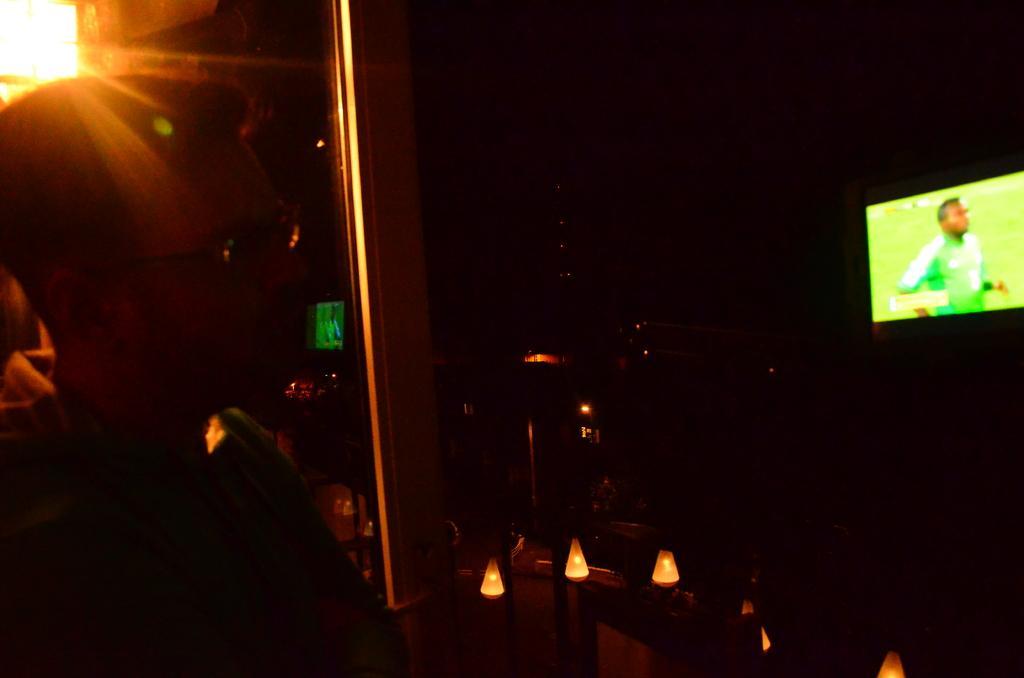Can you describe this image briefly? In this image I can see a man, I can see he is wearing green colour dress and specs. In the background I can see few lights, a screen and on it I can see a man. I can also see this image is in dark from background. 